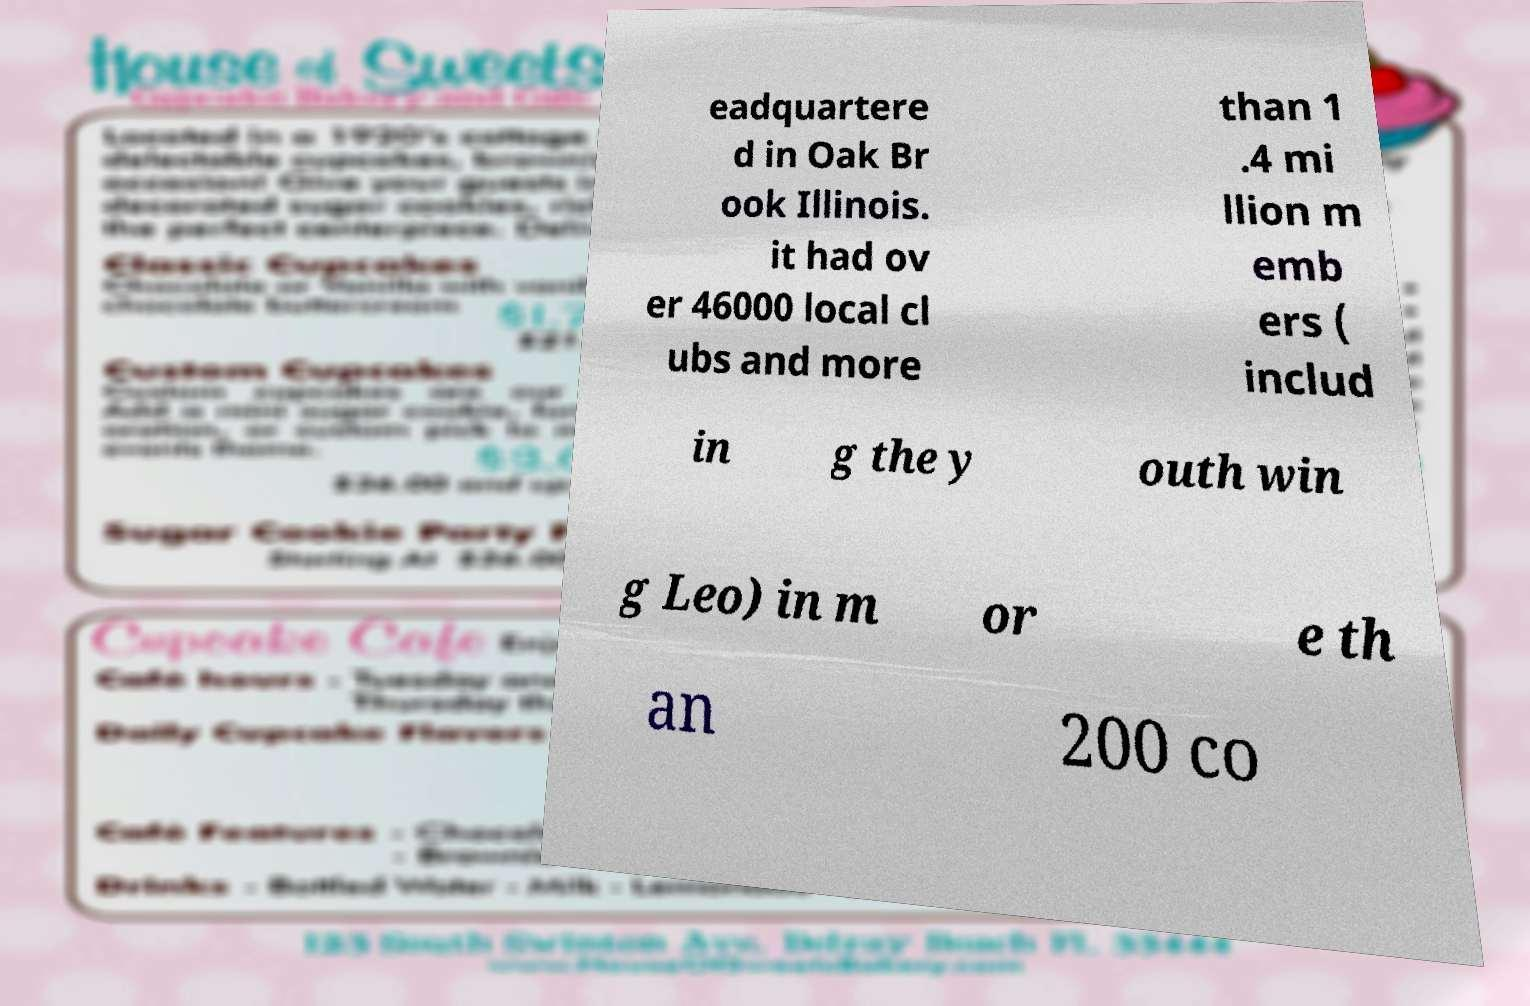I need the written content from this picture converted into text. Can you do that? eadquartere d in Oak Br ook Illinois. it had ov er 46000 local cl ubs and more than 1 .4 mi llion m emb ers ( includ in g the y outh win g Leo) in m or e th an 200 co 